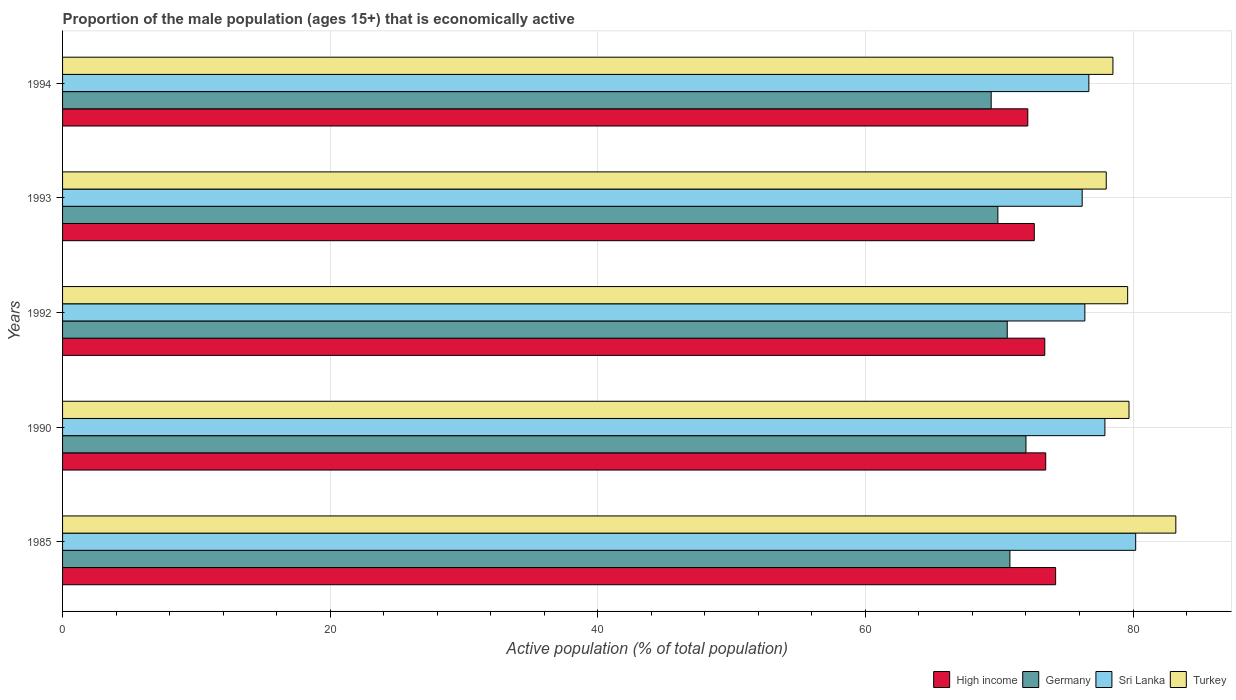How many different coloured bars are there?
Offer a very short reply. 4. How many groups of bars are there?
Offer a very short reply. 5. What is the label of the 2nd group of bars from the top?
Your response must be concise. 1993. In how many cases, is the number of bars for a given year not equal to the number of legend labels?
Provide a short and direct response. 0. What is the proportion of the male population that is economically active in Sri Lanka in 1993?
Ensure brevity in your answer.  76.2. Across all years, what is the maximum proportion of the male population that is economically active in Turkey?
Ensure brevity in your answer.  83.2. Across all years, what is the minimum proportion of the male population that is economically active in Sri Lanka?
Provide a succinct answer. 76.2. In which year was the proportion of the male population that is economically active in Turkey maximum?
Offer a terse response. 1985. In which year was the proportion of the male population that is economically active in Germany minimum?
Make the answer very short. 1994. What is the total proportion of the male population that is economically active in Sri Lanka in the graph?
Offer a terse response. 387.4. What is the difference between the proportion of the male population that is economically active in Sri Lanka in 1990 and that in 1994?
Keep it short and to the point. 1.2. What is the difference between the proportion of the male population that is economically active in High income in 1990 and the proportion of the male population that is economically active in Sri Lanka in 1992?
Ensure brevity in your answer.  -2.92. What is the average proportion of the male population that is economically active in Turkey per year?
Give a very brief answer. 79.8. In the year 1994, what is the difference between the proportion of the male population that is economically active in Turkey and proportion of the male population that is economically active in Germany?
Ensure brevity in your answer.  9.1. What is the ratio of the proportion of the male population that is economically active in Sri Lanka in 1993 to that in 1994?
Keep it short and to the point. 0.99. What is the difference between the highest and the lowest proportion of the male population that is economically active in High income?
Offer a terse response. 2.08. In how many years, is the proportion of the male population that is economically active in Germany greater than the average proportion of the male population that is economically active in Germany taken over all years?
Provide a succinct answer. 3. Is it the case that in every year, the sum of the proportion of the male population that is economically active in Turkey and proportion of the male population that is economically active in High income is greater than the sum of proportion of the male population that is economically active in Germany and proportion of the male population that is economically active in Sri Lanka?
Provide a short and direct response. Yes. What does the 1st bar from the top in 1994 represents?
Offer a very short reply. Turkey. What is the difference between two consecutive major ticks on the X-axis?
Provide a short and direct response. 20. Are the values on the major ticks of X-axis written in scientific E-notation?
Your answer should be compact. No. Does the graph contain any zero values?
Your answer should be compact. No. Where does the legend appear in the graph?
Ensure brevity in your answer.  Bottom right. What is the title of the graph?
Give a very brief answer. Proportion of the male population (ages 15+) that is economically active. Does "Malta" appear as one of the legend labels in the graph?
Keep it short and to the point. No. What is the label or title of the X-axis?
Provide a short and direct response. Active population (% of total population). What is the label or title of the Y-axis?
Your answer should be compact. Years. What is the Active population (% of total population) in High income in 1985?
Give a very brief answer. 74.22. What is the Active population (% of total population) in Germany in 1985?
Your answer should be very brief. 70.8. What is the Active population (% of total population) in Sri Lanka in 1985?
Offer a very short reply. 80.2. What is the Active population (% of total population) of Turkey in 1985?
Keep it short and to the point. 83.2. What is the Active population (% of total population) in High income in 1990?
Offer a terse response. 73.48. What is the Active population (% of total population) in Germany in 1990?
Your response must be concise. 72. What is the Active population (% of total population) in Sri Lanka in 1990?
Keep it short and to the point. 77.9. What is the Active population (% of total population) in Turkey in 1990?
Provide a short and direct response. 79.7. What is the Active population (% of total population) in High income in 1992?
Give a very brief answer. 73.41. What is the Active population (% of total population) of Germany in 1992?
Your answer should be compact. 70.6. What is the Active population (% of total population) of Sri Lanka in 1992?
Offer a terse response. 76.4. What is the Active population (% of total population) in Turkey in 1992?
Offer a terse response. 79.6. What is the Active population (% of total population) of High income in 1993?
Give a very brief answer. 72.62. What is the Active population (% of total population) in Germany in 1993?
Your answer should be compact. 69.9. What is the Active population (% of total population) of Sri Lanka in 1993?
Offer a terse response. 76.2. What is the Active population (% of total population) of Turkey in 1993?
Provide a short and direct response. 78. What is the Active population (% of total population) of High income in 1994?
Offer a terse response. 72.14. What is the Active population (% of total population) of Germany in 1994?
Give a very brief answer. 69.4. What is the Active population (% of total population) of Sri Lanka in 1994?
Ensure brevity in your answer.  76.7. What is the Active population (% of total population) of Turkey in 1994?
Ensure brevity in your answer.  78.5. Across all years, what is the maximum Active population (% of total population) of High income?
Provide a succinct answer. 74.22. Across all years, what is the maximum Active population (% of total population) of Germany?
Provide a short and direct response. 72. Across all years, what is the maximum Active population (% of total population) of Sri Lanka?
Make the answer very short. 80.2. Across all years, what is the maximum Active population (% of total population) in Turkey?
Offer a very short reply. 83.2. Across all years, what is the minimum Active population (% of total population) of High income?
Your answer should be compact. 72.14. Across all years, what is the minimum Active population (% of total population) in Germany?
Make the answer very short. 69.4. Across all years, what is the minimum Active population (% of total population) of Sri Lanka?
Ensure brevity in your answer.  76.2. Across all years, what is the minimum Active population (% of total population) of Turkey?
Keep it short and to the point. 78. What is the total Active population (% of total population) of High income in the graph?
Give a very brief answer. 365.86. What is the total Active population (% of total population) in Germany in the graph?
Make the answer very short. 352.7. What is the total Active population (% of total population) of Sri Lanka in the graph?
Keep it short and to the point. 387.4. What is the total Active population (% of total population) of Turkey in the graph?
Your answer should be compact. 399. What is the difference between the Active population (% of total population) of High income in 1985 and that in 1990?
Keep it short and to the point. 0.74. What is the difference between the Active population (% of total population) of High income in 1985 and that in 1992?
Your answer should be compact. 0.81. What is the difference between the Active population (% of total population) in Turkey in 1985 and that in 1992?
Give a very brief answer. 3.6. What is the difference between the Active population (% of total population) in High income in 1985 and that in 1993?
Provide a succinct answer. 1.59. What is the difference between the Active population (% of total population) of Germany in 1985 and that in 1993?
Your answer should be very brief. 0.9. What is the difference between the Active population (% of total population) in High income in 1985 and that in 1994?
Offer a terse response. 2.08. What is the difference between the Active population (% of total population) in Germany in 1985 and that in 1994?
Keep it short and to the point. 1.4. What is the difference between the Active population (% of total population) of High income in 1990 and that in 1992?
Keep it short and to the point. 0.07. What is the difference between the Active population (% of total population) in High income in 1990 and that in 1993?
Give a very brief answer. 0.85. What is the difference between the Active population (% of total population) of Sri Lanka in 1990 and that in 1993?
Give a very brief answer. 1.7. What is the difference between the Active population (% of total population) of High income in 1990 and that in 1994?
Your answer should be very brief. 1.34. What is the difference between the Active population (% of total population) of Germany in 1990 and that in 1994?
Make the answer very short. 2.6. What is the difference between the Active population (% of total population) of Sri Lanka in 1990 and that in 1994?
Offer a terse response. 1.2. What is the difference between the Active population (% of total population) of High income in 1992 and that in 1993?
Give a very brief answer. 0.78. What is the difference between the Active population (% of total population) of Sri Lanka in 1992 and that in 1993?
Offer a terse response. 0.2. What is the difference between the Active population (% of total population) in Turkey in 1992 and that in 1993?
Offer a terse response. 1.6. What is the difference between the Active population (% of total population) of High income in 1992 and that in 1994?
Keep it short and to the point. 1.27. What is the difference between the Active population (% of total population) in Sri Lanka in 1992 and that in 1994?
Provide a succinct answer. -0.3. What is the difference between the Active population (% of total population) in Turkey in 1992 and that in 1994?
Provide a short and direct response. 1.1. What is the difference between the Active population (% of total population) in High income in 1993 and that in 1994?
Provide a short and direct response. 0.49. What is the difference between the Active population (% of total population) of Germany in 1993 and that in 1994?
Make the answer very short. 0.5. What is the difference between the Active population (% of total population) in High income in 1985 and the Active population (% of total population) in Germany in 1990?
Offer a very short reply. 2.22. What is the difference between the Active population (% of total population) in High income in 1985 and the Active population (% of total population) in Sri Lanka in 1990?
Your answer should be very brief. -3.68. What is the difference between the Active population (% of total population) in High income in 1985 and the Active population (% of total population) in Turkey in 1990?
Your response must be concise. -5.48. What is the difference between the Active population (% of total population) of Germany in 1985 and the Active population (% of total population) of Sri Lanka in 1990?
Keep it short and to the point. -7.1. What is the difference between the Active population (% of total population) in Germany in 1985 and the Active population (% of total population) in Turkey in 1990?
Offer a very short reply. -8.9. What is the difference between the Active population (% of total population) in Sri Lanka in 1985 and the Active population (% of total population) in Turkey in 1990?
Offer a terse response. 0.5. What is the difference between the Active population (% of total population) in High income in 1985 and the Active population (% of total population) in Germany in 1992?
Keep it short and to the point. 3.62. What is the difference between the Active population (% of total population) in High income in 1985 and the Active population (% of total population) in Sri Lanka in 1992?
Ensure brevity in your answer.  -2.18. What is the difference between the Active population (% of total population) of High income in 1985 and the Active population (% of total population) of Turkey in 1992?
Provide a short and direct response. -5.38. What is the difference between the Active population (% of total population) of Germany in 1985 and the Active population (% of total population) of Turkey in 1992?
Provide a short and direct response. -8.8. What is the difference between the Active population (% of total population) of High income in 1985 and the Active population (% of total population) of Germany in 1993?
Keep it short and to the point. 4.32. What is the difference between the Active population (% of total population) of High income in 1985 and the Active population (% of total population) of Sri Lanka in 1993?
Your response must be concise. -1.98. What is the difference between the Active population (% of total population) of High income in 1985 and the Active population (% of total population) of Turkey in 1993?
Your answer should be very brief. -3.78. What is the difference between the Active population (% of total population) of Germany in 1985 and the Active population (% of total population) of Turkey in 1993?
Your answer should be very brief. -7.2. What is the difference between the Active population (% of total population) in Sri Lanka in 1985 and the Active population (% of total population) in Turkey in 1993?
Your answer should be compact. 2.2. What is the difference between the Active population (% of total population) of High income in 1985 and the Active population (% of total population) of Germany in 1994?
Your response must be concise. 4.82. What is the difference between the Active population (% of total population) in High income in 1985 and the Active population (% of total population) in Sri Lanka in 1994?
Provide a short and direct response. -2.48. What is the difference between the Active population (% of total population) of High income in 1985 and the Active population (% of total population) of Turkey in 1994?
Offer a very short reply. -4.28. What is the difference between the Active population (% of total population) in Germany in 1985 and the Active population (% of total population) in Turkey in 1994?
Ensure brevity in your answer.  -7.7. What is the difference between the Active population (% of total population) in High income in 1990 and the Active population (% of total population) in Germany in 1992?
Your answer should be compact. 2.88. What is the difference between the Active population (% of total population) of High income in 1990 and the Active population (% of total population) of Sri Lanka in 1992?
Offer a terse response. -2.92. What is the difference between the Active population (% of total population) of High income in 1990 and the Active population (% of total population) of Turkey in 1992?
Your answer should be compact. -6.12. What is the difference between the Active population (% of total population) in Germany in 1990 and the Active population (% of total population) in Sri Lanka in 1992?
Make the answer very short. -4.4. What is the difference between the Active population (% of total population) in High income in 1990 and the Active population (% of total population) in Germany in 1993?
Provide a succinct answer. 3.58. What is the difference between the Active population (% of total population) of High income in 1990 and the Active population (% of total population) of Sri Lanka in 1993?
Give a very brief answer. -2.72. What is the difference between the Active population (% of total population) in High income in 1990 and the Active population (% of total population) in Turkey in 1993?
Provide a short and direct response. -4.52. What is the difference between the Active population (% of total population) in Germany in 1990 and the Active population (% of total population) in Turkey in 1993?
Provide a short and direct response. -6. What is the difference between the Active population (% of total population) of Sri Lanka in 1990 and the Active population (% of total population) of Turkey in 1993?
Your answer should be very brief. -0.1. What is the difference between the Active population (% of total population) of High income in 1990 and the Active population (% of total population) of Germany in 1994?
Offer a terse response. 4.08. What is the difference between the Active population (% of total population) in High income in 1990 and the Active population (% of total population) in Sri Lanka in 1994?
Your response must be concise. -3.22. What is the difference between the Active population (% of total population) of High income in 1990 and the Active population (% of total population) of Turkey in 1994?
Give a very brief answer. -5.02. What is the difference between the Active population (% of total population) in Germany in 1990 and the Active population (% of total population) in Turkey in 1994?
Your response must be concise. -6.5. What is the difference between the Active population (% of total population) of High income in 1992 and the Active population (% of total population) of Germany in 1993?
Your answer should be compact. 3.51. What is the difference between the Active population (% of total population) of High income in 1992 and the Active population (% of total population) of Sri Lanka in 1993?
Give a very brief answer. -2.79. What is the difference between the Active population (% of total population) in High income in 1992 and the Active population (% of total population) in Turkey in 1993?
Your answer should be compact. -4.59. What is the difference between the Active population (% of total population) of Sri Lanka in 1992 and the Active population (% of total population) of Turkey in 1993?
Make the answer very short. -1.6. What is the difference between the Active population (% of total population) of High income in 1992 and the Active population (% of total population) of Germany in 1994?
Your response must be concise. 4.01. What is the difference between the Active population (% of total population) in High income in 1992 and the Active population (% of total population) in Sri Lanka in 1994?
Your answer should be very brief. -3.29. What is the difference between the Active population (% of total population) of High income in 1992 and the Active population (% of total population) of Turkey in 1994?
Your answer should be compact. -5.09. What is the difference between the Active population (% of total population) of Germany in 1992 and the Active population (% of total population) of Turkey in 1994?
Your answer should be very brief. -7.9. What is the difference between the Active population (% of total population) of High income in 1993 and the Active population (% of total population) of Germany in 1994?
Offer a terse response. 3.22. What is the difference between the Active population (% of total population) in High income in 1993 and the Active population (% of total population) in Sri Lanka in 1994?
Offer a terse response. -4.08. What is the difference between the Active population (% of total population) in High income in 1993 and the Active population (% of total population) in Turkey in 1994?
Offer a very short reply. -5.88. What is the difference between the Active population (% of total population) in Germany in 1993 and the Active population (% of total population) in Sri Lanka in 1994?
Ensure brevity in your answer.  -6.8. What is the average Active population (% of total population) of High income per year?
Offer a very short reply. 73.17. What is the average Active population (% of total population) of Germany per year?
Provide a succinct answer. 70.54. What is the average Active population (% of total population) of Sri Lanka per year?
Ensure brevity in your answer.  77.48. What is the average Active population (% of total population) in Turkey per year?
Provide a short and direct response. 79.8. In the year 1985, what is the difference between the Active population (% of total population) of High income and Active population (% of total population) of Germany?
Your answer should be compact. 3.42. In the year 1985, what is the difference between the Active population (% of total population) in High income and Active population (% of total population) in Sri Lanka?
Give a very brief answer. -5.98. In the year 1985, what is the difference between the Active population (% of total population) in High income and Active population (% of total population) in Turkey?
Your answer should be compact. -8.98. In the year 1985, what is the difference between the Active population (% of total population) of Germany and Active population (% of total population) of Sri Lanka?
Provide a short and direct response. -9.4. In the year 1985, what is the difference between the Active population (% of total population) in Sri Lanka and Active population (% of total population) in Turkey?
Make the answer very short. -3. In the year 1990, what is the difference between the Active population (% of total population) of High income and Active population (% of total population) of Germany?
Offer a very short reply. 1.48. In the year 1990, what is the difference between the Active population (% of total population) of High income and Active population (% of total population) of Sri Lanka?
Offer a terse response. -4.42. In the year 1990, what is the difference between the Active population (% of total population) in High income and Active population (% of total population) in Turkey?
Provide a succinct answer. -6.22. In the year 1990, what is the difference between the Active population (% of total population) in Germany and Active population (% of total population) in Sri Lanka?
Provide a short and direct response. -5.9. In the year 1990, what is the difference between the Active population (% of total population) in Germany and Active population (% of total population) in Turkey?
Provide a succinct answer. -7.7. In the year 1992, what is the difference between the Active population (% of total population) in High income and Active population (% of total population) in Germany?
Offer a terse response. 2.81. In the year 1992, what is the difference between the Active population (% of total population) in High income and Active population (% of total population) in Sri Lanka?
Your answer should be compact. -2.99. In the year 1992, what is the difference between the Active population (% of total population) of High income and Active population (% of total population) of Turkey?
Keep it short and to the point. -6.19. In the year 1992, what is the difference between the Active population (% of total population) in Germany and Active population (% of total population) in Sri Lanka?
Provide a succinct answer. -5.8. In the year 1993, what is the difference between the Active population (% of total population) of High income and Active population (% of total population) of Germany?
Make the answer very short. 2.72. In the year 1993, what is the difference between the Active population (% of total population) in High income and Active population (% of total population) in Sri Lanka?
Provide a short and direct response. -3.58. In the year 1993, what is the difference between the Active population (% of total population) of High income and Active population (% of total population) of Turkey?
Keep it short and to the point. -5.38. In the year 1993, what is the difference between the Active population (% of total population) of Sri Lanka and Active population (% of total population) of Turkey?
Your answer should be compact. -1.8. In the year 1994, what is the difference between the Active population (% of total population) of High income and Active population (% of total population) of Germany?
Your answer should be very brief. 2.74. In the year 1994, what is the difference between the Active population (% of total population) in High income and Active population (% of total population) in Sri Lanka?
Offer a very short reply. -4.56. In the year 1994, what is the difference between the Active population (% of total population) in High income and Active population (% of total population) in Turkey?
Ensure brevity in your answer.  -6.36. In the year 1994, what is the difference between the Active population (% of total population) in Germany and Active population (% of total population) in Sri Lanka?
Offer a terse response. -7.3. What is the ratio of the Active population (% of total population) in High income in 1985 to that in 1990?
Make the answer very short. 1.01. What is the ratio of the Active population (% of total population) in Germany in 1985 to that in 1990?
Your answer should be compact. 0.98. What is the ratio of the Active population (% of total population) in Sri Lanka in 1985 to that in 1990?
Your response must be concise. 1.03. What is the ratio of the Active population (% of total population) of Turkey in 1985 to that in 1990?
Provide a short and direct response. 1.04. What is the ratio of the Active population (% of total population) in High income in 1985 to that in 1992?
Give a very brief answer. 1.01. What is the ratio of the Active population (% of total population) in Sri Lanka in 1985 to that in 1992?
Give a very brief answer. 1.05. What is the ratio of the Active population (% of total population) of Turkey in 1985 to that in 1992?
Provide a succinct answer. 1.05. What is the ratio of the Active population (% of total population) in High income in 1985 to that in 1993?
Your response must be concise. 1.02. What is the ratio of the Active population (% of total population) of Germany in 1985 to that in 1993?
Your answer should be compact. 1.01. What is the ratio of the Active population (% of total population) of Sri Lanka in 1985 to that in 1993?
Keep it short and to the point. 1.05. What is the ratio of the Active population (% of total population) in Turkey in 1985 to that in 1993?
Provide a succinct answer. 1.07. What is the ratio of the Active population (% of total population) in High income in 1985 to that in 1994?
Offer a terse response. 1.03. What is the ratio of the Active population (% of total population) in Germany in 1985 to that in 1994?
Keep it short and to the point. 1.02. What is the ratio of the Active population (% of total population) of Sri Lanka in 1985 to that in 1994?
Ensure brevity in your answer.  1.05. What is the ratio of the Active population (% of total population) of Turkey in 1985 to that in 1994?
Provide a short and direct response. 1.06. What is the ratio of the Active population (% of total population) of Germany in 1990 to that in 1992?
Provide a short and direct response. 1.02. What is the ratio of the Active population (% of total population) in Sri Lanka in 1990 to that in 1992?
Provide a short and direct response. 1.02. What is the ratio of the Active population (% of total population) in Turkey in 1990 to that in 1992?
Ensure brevity in your answer.  1. What is the ratio of the Active population (% of total population) in High income in 1990 to that in 1993?
Provide a succinct answer. 1.01. What is the ratio of the Active population (% of total population) in Sri Lanka in 1990 to that in 1993?
Provide a short and direct response. 1.02. What is the ratio of the Active population (% of total population) in Turkey in 1990 to that in 1993?
Ensure brevity in your answer.  1.02. What is the ratio of the Active population (% of total population) in High income in 1990 to that in 1994?
Your answer should be compact. 1.02. What is the ratio of the Active population (% of total population) of Germany in 1990 to that in 1994?
Provide a succinct answer. 1.04. What is the ratio of the Active population (% of total population) in Sri Lanka in 1990 to that in 1994?
Give a very brief answer. 1.02. What is the ratio of the Active population (% of total population) in Turkey in 1990 to that in 1994?
Ensure brevity in your answer.  1.02. What is the ratio of the Active population (% of total population) of High income in 1992 to that in 1993?
Give a very brief answer. 1.01. What is the ratio of the Active population (% of total population) in Germany in 1992 to that in 1993?
Your answer should be very brief. 1.01. What is the ratio of the Active population (% of total population) in Sri Lanka in 1992 to that in 1993?
Your answer should be very brief. 1. What is the ratio of the Active population (% of total population) of Turkey in 1992 to that in 1993?
Your answer should be compact. 1.02. What is the ratio of the Active population (% of total population) of High income in 1992 to that in 1994?
Give a very brief answer. 1.02. What is the ratio of the Active population (% of total population) of Germany in 1992 to that in 1994?
Keep it short and to the point. 1.02. What is the ratio of the Active population (% of total population) of High income in 1993 to that in 1994?
Keep it short and to the point. 1.01. What is the difference between the highest and the second highest Active population (% of total population) of High income?
Provide a succinct answer. 0.74. What is the difference between the highest and the second highest Active population (% of total population) in Germany?
Ensure brevity in your answer.  1.2. What is the difference between the highest and the second highest Active population (% of total population) in Turkey?
Your answer should be compact. 3.5. What is the difference between the highest and the lowest Active population (% of total population) in High income?
Ensure brevity in your answer.  2.08. What is the difference between the highest and the lowest Active population (% of total population) of Germany?
Your answer should be very brief. 2.6. What is the difference between the highest and the lowest Active population (% of total population) of Sri Lanka?
Your answer should be compact. 4. What is the difference between the highest and the lowest Active population (% of total population) in Turkey?
Provide a short and direct response. 5.2. 